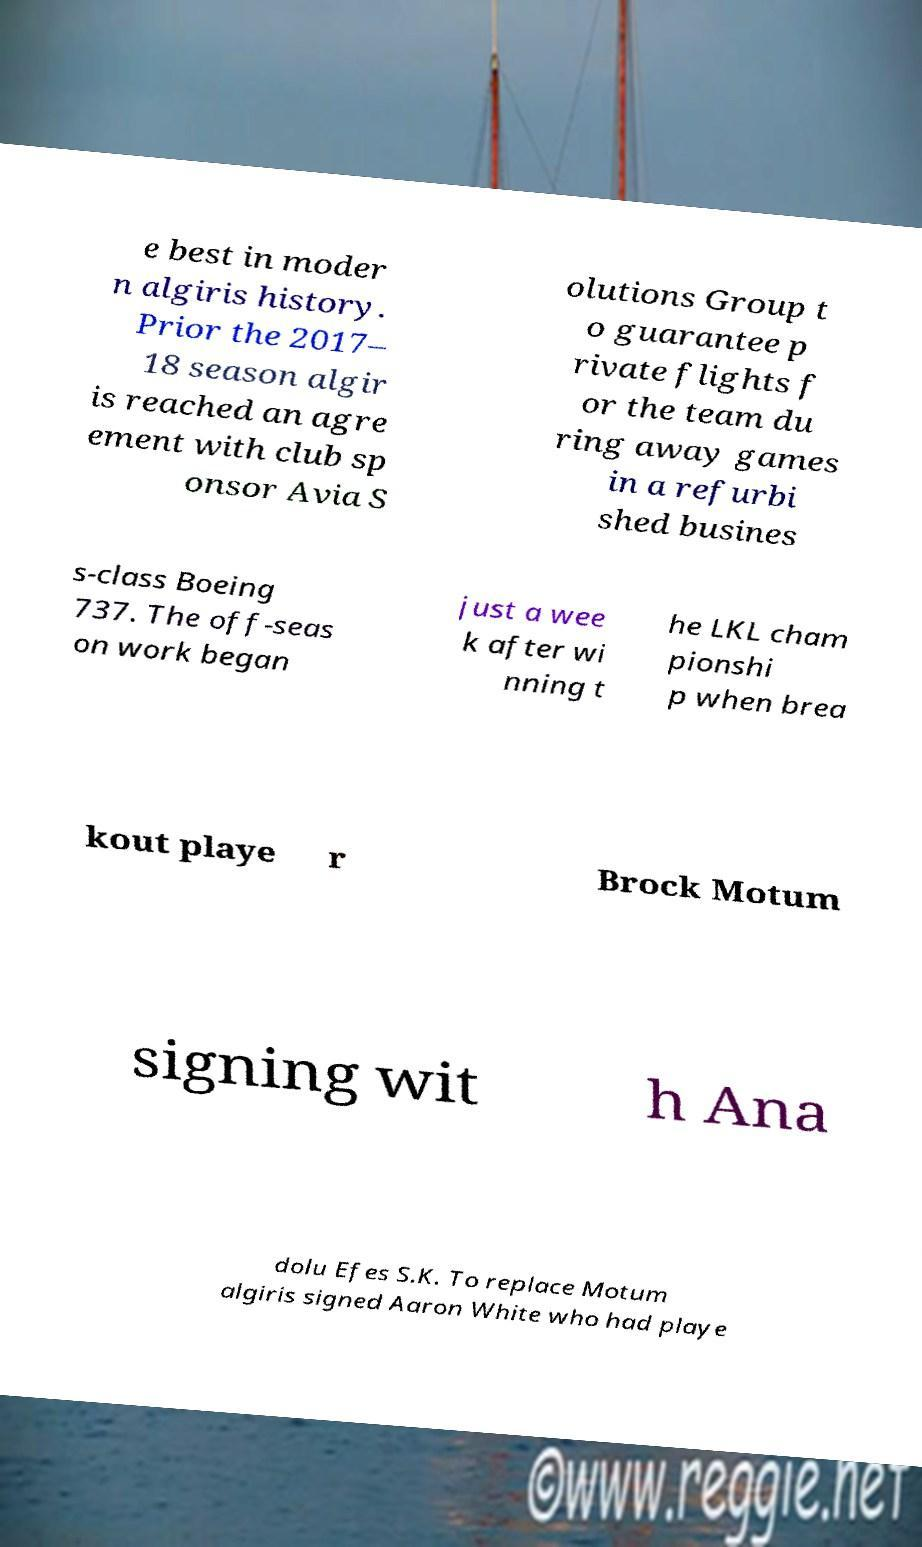Can you read and provide the text displayed in the image?This photo seems to have some interesting text. Can you extract and type it out for me? e best in moder n algiris history. Prior the 2017– 18 season algir is reached an agre ement with club sp onsor Avia S olutions Group t o guarantee p rivate flights f or the team du ring away games in a refurbi shed busines s-class Boeing 737. The off-seas on work began just a wee k after wi nning t he LKL cham pionshi p when brea kout playe r Brock Motum signing wit h Ana dolu Efes S.K. To replace Motum algiris signed Aaron White who had playe 